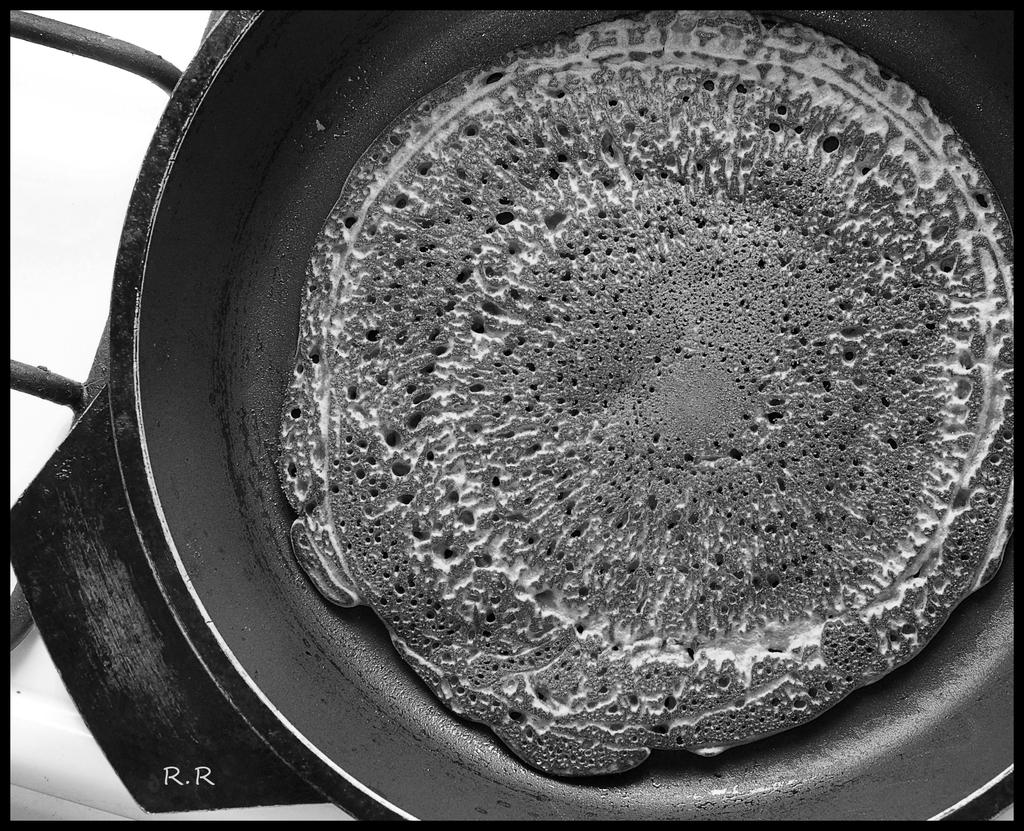What type of clothing is visible in the image? There is a black color pant in the image. What is placed inside the pant? Eatables are placed in the pant. Where is the vase located in the image? There is no vase present in the image. What type of drink is being served in the image? There is no drink being served in the image; only eatables are placed inside the pant. 